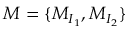<formula> <loc_0><loc_0><loc_500><loc_500>M = \{ M _ { I _ { 1 } } , M _ { I _ { 2 } } \}</formula> 